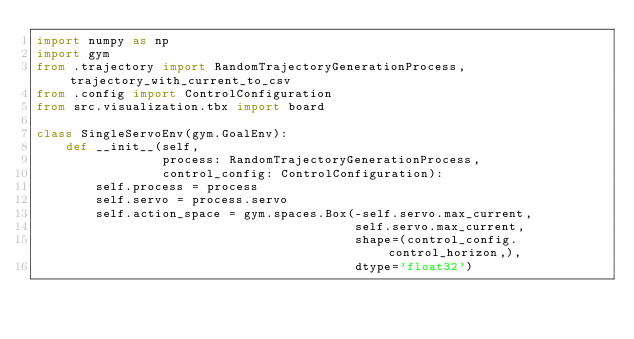Convert code to text. <code><loc_0><loc_0><loc_500><loc_500><_Python_>import numpy as np
import gym
from .trajectory import RandomTrajectoryGenerationProcess, trajectory_with_current_to_csv
from .config import ControlConfiguration
from src.visualization.tbx import board

class SingleServoEnv(gym.GoalEnv):
    def __init__(self,
                 process: RandomTrajectoryGenerationProcess,
                 control_config: ControlConfiguration):
        self.process = process
        self.servo = process.servo
        self.action_space = gym.spaces.Box(-self.servo.max_current,
                                           self.servo.max_current,
                                           shape=(control_config.control_horizon,),
                                           dtype='float32')</code> 